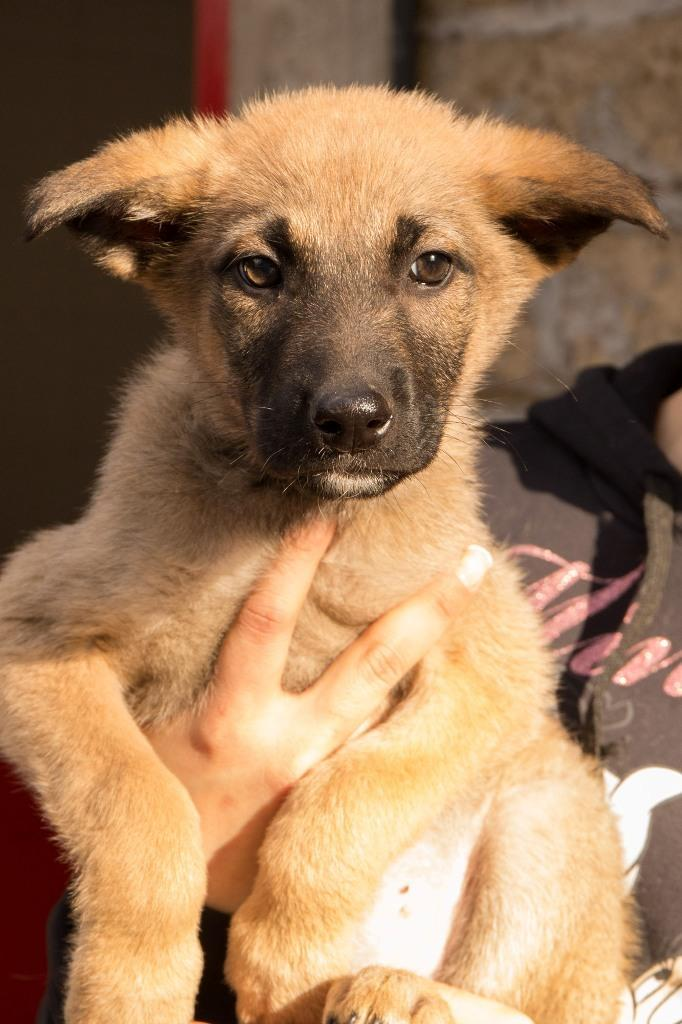Who or what is the main subject in the image? There is a person in the image. What is the person doing in the image? The person is holding a dog. What can be seen in the background of the image? There is a wall in the background of the image. What type of glass is the person wearing around their neck in the image? There is no glass visible around the person's neck in the image. Is the person in the image a doctor? The provided facts do not mention the person's profession, so we cannot determine if they are a doctor. 